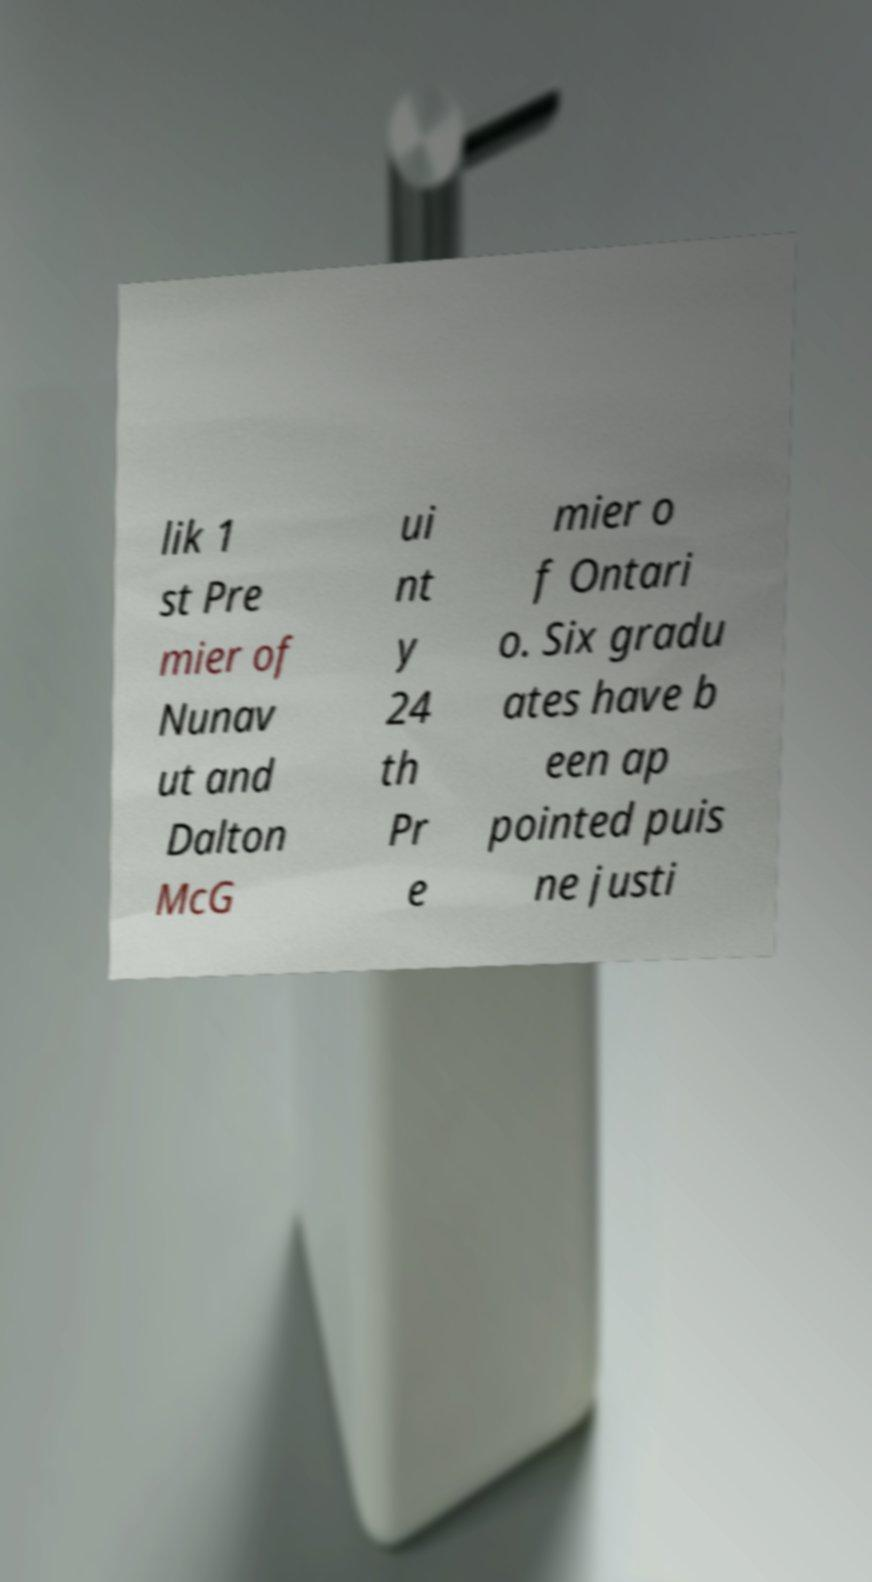Please identify and transcribe the text found in this image. lik 1 st Pre mier of Nunav ut and Dalton McG ui nt y 24 th Pr e mier o f Ontari o. Six gradu ates have b een ap pointed puis ne justi 